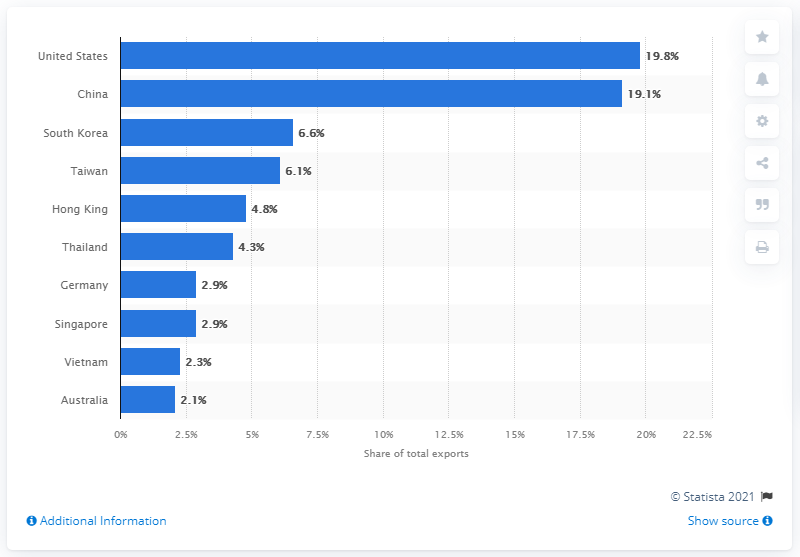Identify some key points in this picture. In 2019, the United States accounted for 19.8% of Japan's total exports. 